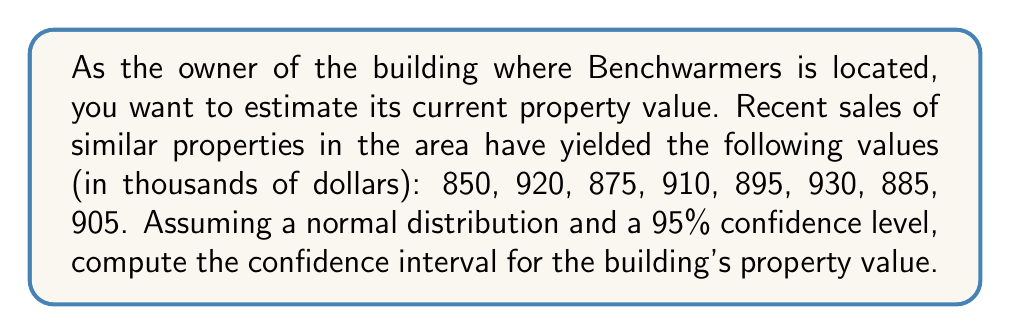Help me with this question. To compute the confidence interval, we'll follow these steps:

1. Calculate the sample mean ($\bar{x}$):
   $$\bar{x} = \frac{850 + 920 + 875 + 910 + 895 + 930 + 885 + 905}{8} = 896.25$$

2. Calculate the sample standard deviation ($s$):
   $$s = \sqrt{\frac{\sum_{i=1}^{n} (x_i - \bar{x})^2}{n-1}}$$
   $$s \approx 26.69$$

3. Determine the critical value ($t$) for a 95% confidence level with 7 degrees of freedom (n-1):
   $t_{0.025,7} = 2.365$ (from t-distribution table)

4. Calculate the margin of error:
   $$\text{Margin of Error} = t \cdot \frac{s}{\sqrt{n}} = 2.365 \cdot \frac{26.69}{\sqrt{8}} \approx 22.29$$

5. Compute the confidence interval:
   $$\text{CI} = \bar{x} \pm \text{Margin of Error}$$
   $$\text{CI} = 896.25 \pm 22.29$$
   $$\text{Lower bound} = 896.25 - 22.29 = 873.96$$
   $$\text{Upper bound} = 896.25 + 22.29 = 918.54$$
Answer: (873.96, 918.54) thousand dollars 